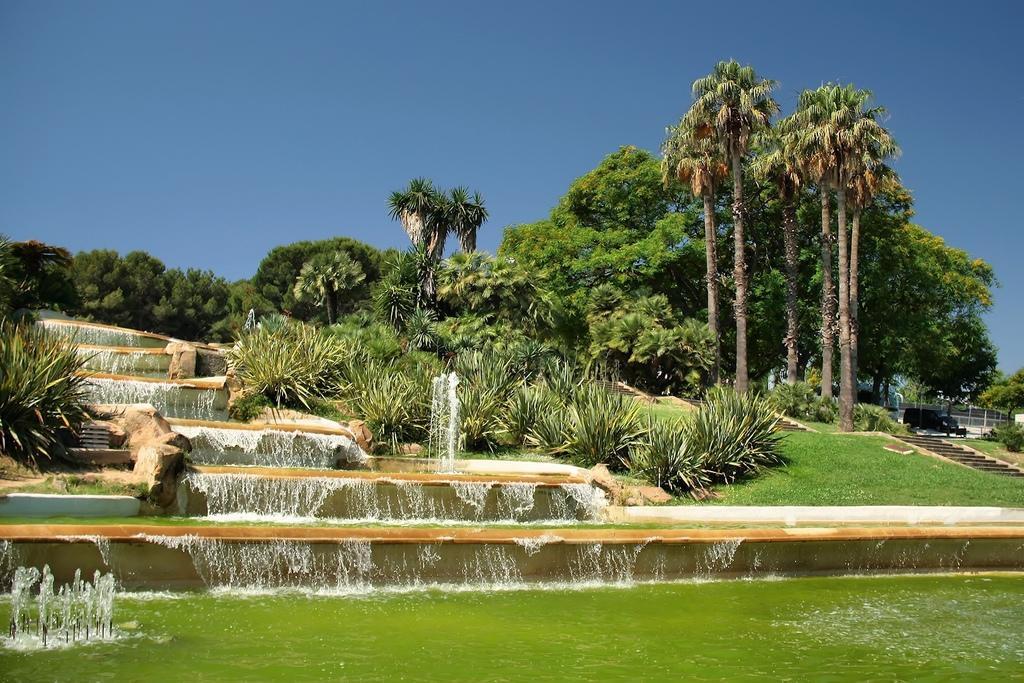Please provide a concise description of this image. These are the water flowing. I can see a small water fountain. These are the rocks. I can see the plants and trees. These are the stairs. This looks like a vehicle, which is parked. 